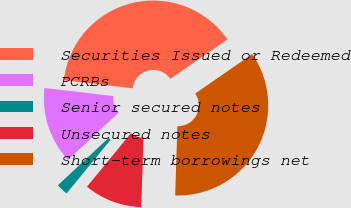Convert chart. <chart><loc_0><loc_0><loc_500><loc_500><pie_chart><fcel>Securities Issued or Redeemed<fcel>PCRBs<fcel>Senior secured notes<fcel>Unsecured notes<fcel>Short-term borrowings net<nl><fcel>38.52%<fcel>13.8%<fcel>2.11%<fcel>10.42%<fcel>35.14%<nl></chart> 